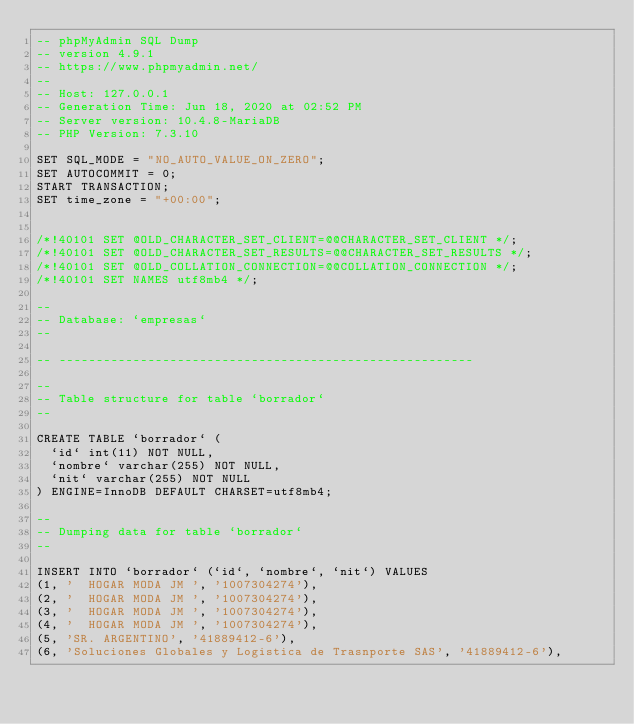Convert code to text. <code><loc_0><loc_0><loc_500><loc_500><_SQL_>-- phpMyAdmin SQL Dump
-- version 4.9.1
-- https://www.phpmyadmin.net/
--
-- Host: 127.0.0.1
-- Generation Time: Jun 18, 2020 at 02:52 PM
-- Server version: 10.4.8-MariaDB
-- PHP Version: 7.3.10

SET SQL_MODE = "NO_AUTO_VALUE_ON_ZERO";
SET AUTOCOMMIT = 0;
START TRANSACTION;
SET time_zone = "+00:00";


/*!40101 SET @OLD_CHARACTER_SET_CLIENT=@@CHARACTER_SET_CLIENT */;
/*!40101 SET @OLD_CHARACTER_SET_RESULTS=@@CHARACTER_SET_RESULTS */;
/*!40101 SET @OLD_COLLATION_CONNECTION=@@COLLATION_CONNECTION */;
/*!40101 SET NAMES utf8mb4 */;

--
-- Database: `empresas`
--

-- --------------------------------------------------------

--
-- Table structure for table `borrador`
--

CREATE TABLE `borrador` (
  `id` int(11) NOT NULL,
  `nombre` varchar(255) NOT NULL,
  `nit` varchar(255) NOT NULL
) ENGINE=InnoDB DEFAULT CHARSET=utf8mb4;

--
-- Dumping data for table `borrador`
--

INSERT INTO `borrador` (`id`, `nombre`, `nit`) VALUES
(1, '  HOGAR MODA JM ', '1007304274'),
(2, '  HOGAR MODA JM ', '1007304274'),
(3, '  HOGAR MODA JM ', '1007304274'),
(4, '  HOGAR MODA JM ', '1007304274'),
(5, 'SR. ARGENTINO', '41889412-6'),
(6, 'Soluciones Globales y Logistica de Trasnporte SAS', '41889412-6'),</code> 